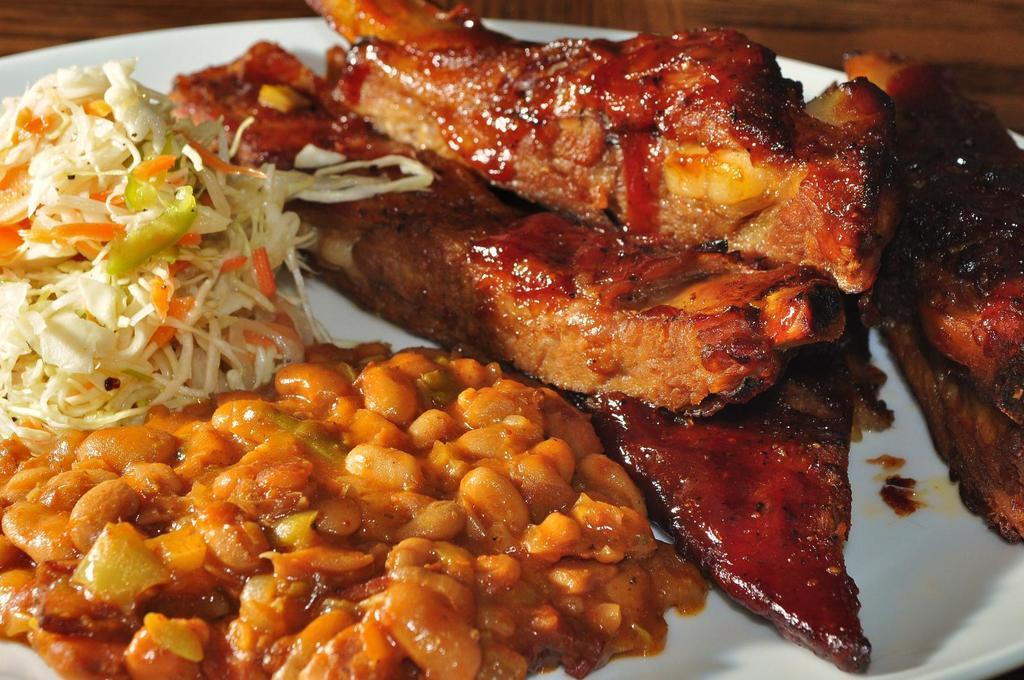What is on the plate in the image? There are food items on the plate in the image. Where is the plate located? The plate is on a table. What type of cord is connected to the food items in the image? There is no cord connected to the food items in the image. What does the grandmother say about the food in the image? There is no grandmother present in the image, so it is not possible to determine what she might say about the food. 